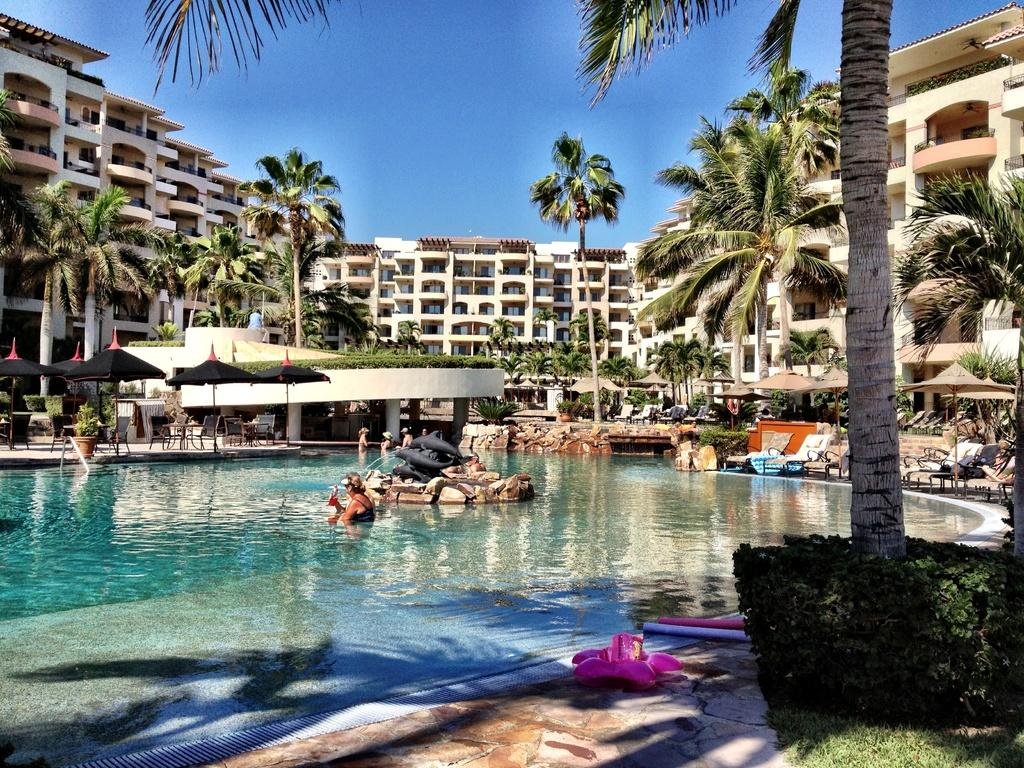What is the main feature of the image? There is a swimming pool in the image. What other objects or structures can be seen in the image? There are statues, grass, plants, chairs, people, umbrellas, trees, and buildings in the image. Can you describe the natural elements in the image? There is grass, plants, and trees in the image. What is visible in the background of the image? The sky is visible in the background of the image. How many unspecified objects are present in the image? There are a few unspecified objects in the image. What type of sugar can be seen in the image? There is no sugar present in the image. Can you hear the voice of the person in the image? The image is a still photograph, so there is no sound or voice present. Is there an ant crawling on the person in the image? There is no ant visible in the image. 